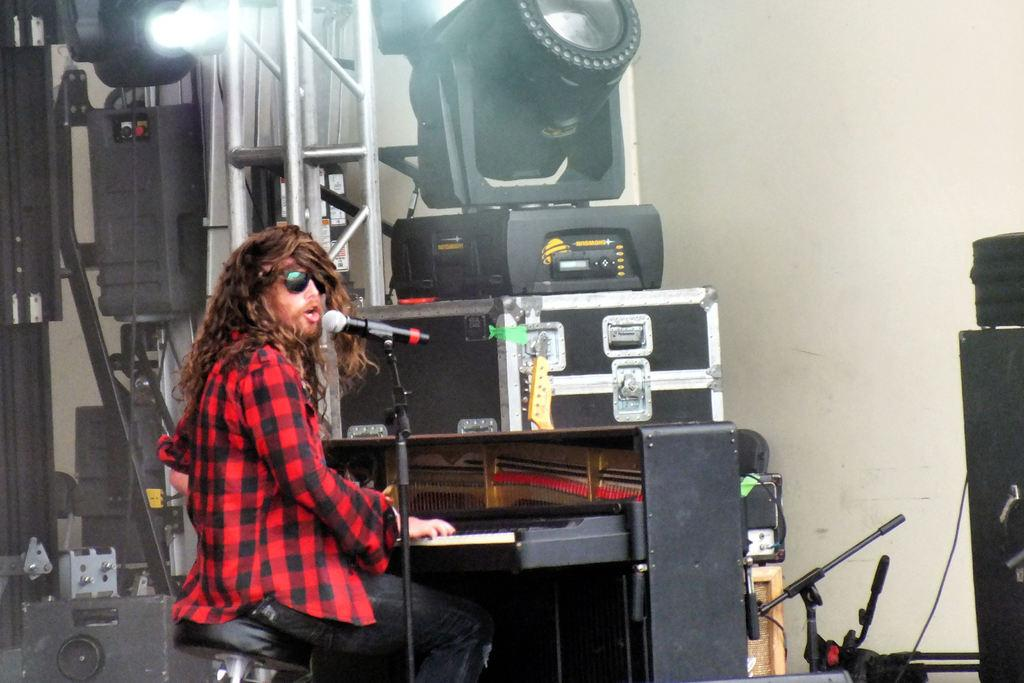What is the source of light in the image? There is a focusing light in the image. What else can be seen in the image besides the light? There are electronic devices, a man sitting on a chair, a piano, a microphone, a box, and a rod in the image. What is the man doing in the image? The man is playing a piano. What is in front of the piano? There is a microphone in front of the piano. How many trucks are visible in the image? There are no trucks present in the image. What type of bridge is shown in the image? There is no bridge present in the image. 